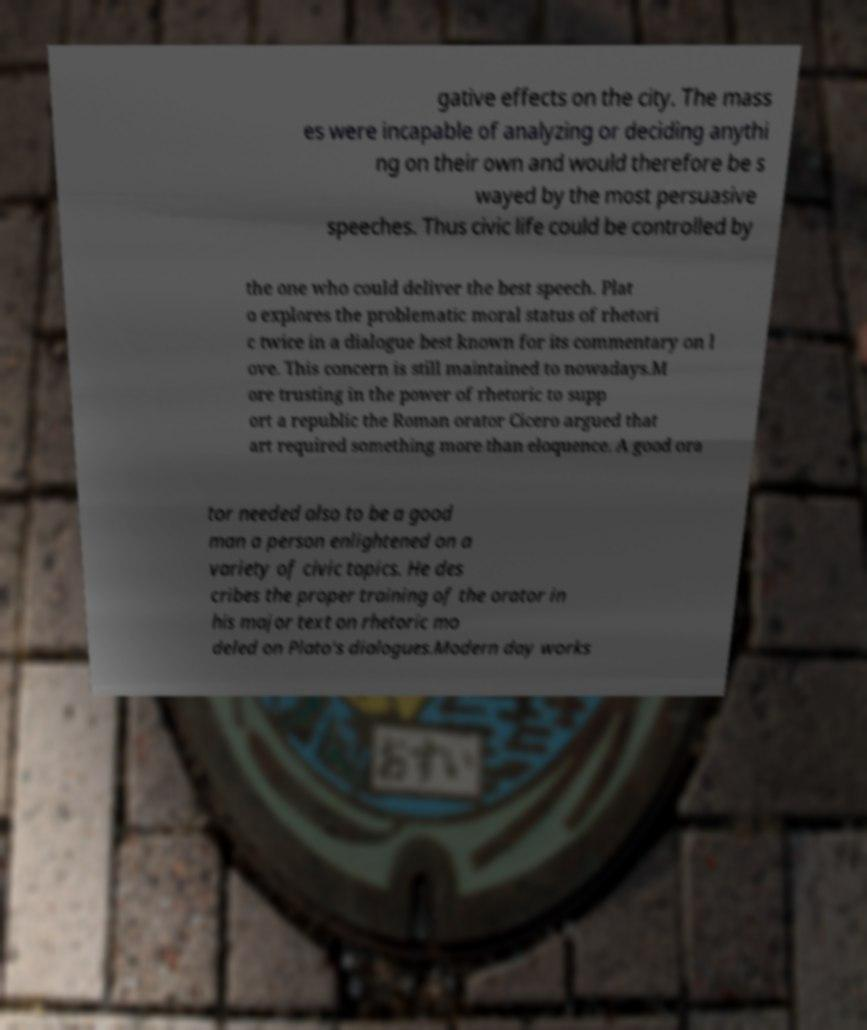I need the written content from this picture converted into text. Can you do that? gative effects on the city. The mass es were incapable of analyzing or deciding anythi ng on their own and would therefore be s wayed by the most persuasive speeches. Thus civic life could be controlled by the one who could deliver the best speech. Plat o explores the problematic moral status of rhetori c twice in a dialogue best known for its commentary on l ove. This concern is still maintained to nowadays.M ore trusting in the power of rhetoric to supp ort a republic the Roman orator Cicero argued that art required something more than eloquence. A good ora tor needed also to be a good man a person enlightened on a variety of civic topics. He des cribes the proper training of the orator in his major text on rhetoric mo deled on Plato's dialogues.Modern day works 